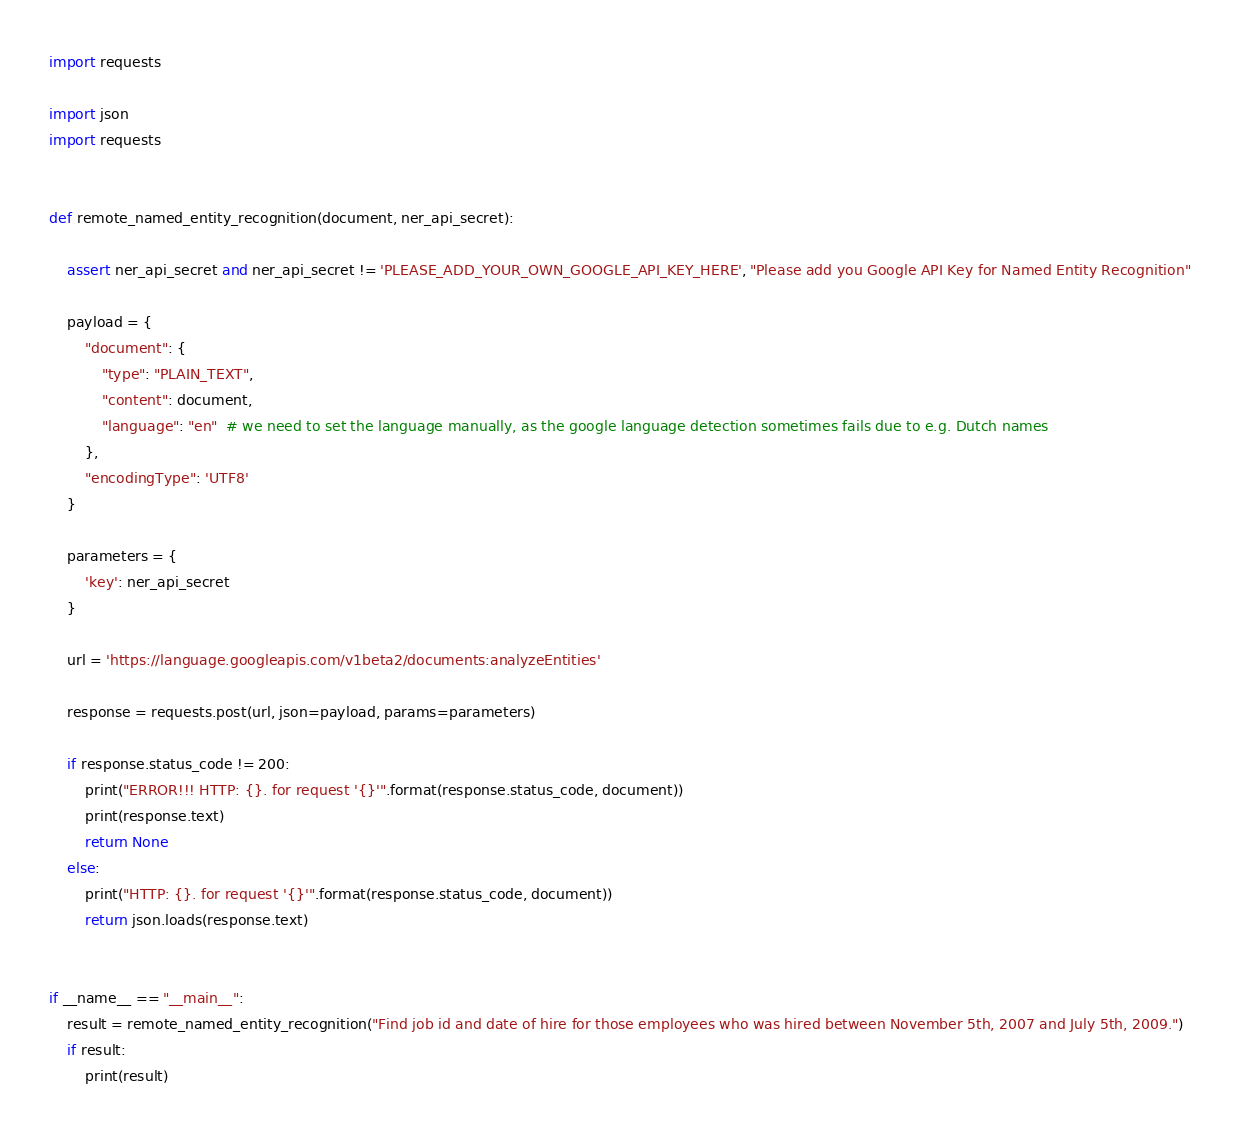Convert code to text. <code><loc_0><loc_0><loc_500><loc_500><_Python_>import requests

import json
import requests


def remote_named_entity_recognition(document, ner_api_secret):

    assert ner_api_secret and ner_api_secret != 'PLEASE_ADD_YOUR_OWN_GOOGLE_API_KEY_HERE', "Please add you Google API Key for Named Entity Recognition"

    payload = {
        "document": {
            "type": "PLAIN_TEXT",
            "content": document,
            "language": "en"  # we need to set the language manually, as the google language detection sometimes fails due to e.g. Dutch names
        },
        "encodingType": 'UTF8'
    }

    parameters = {
        'key': ner_api_secret
    }

    url = 'https://language.googleapis.com/v1beta2/documents:analyzeEntities'

    response = requests.post(url, json=payload, params=parameters)

    if response.status_code != 200:
        print("ERROR!!! HTTP: {}. for request '{}'".format(response.status_code, document))
        print(response.text)
        return None
    else:
        print("HTTP: {}. for request '{}'".format(response.status_code, document))
        return json.loads(response.text)


if __name__ == "__main__":
    result = remote_named_entity_recognition("Find job id and date of hire for those employees who was hired between November 5th, 2007 and July 5th, 2009.")
    if result:
        print(result)
</code> 